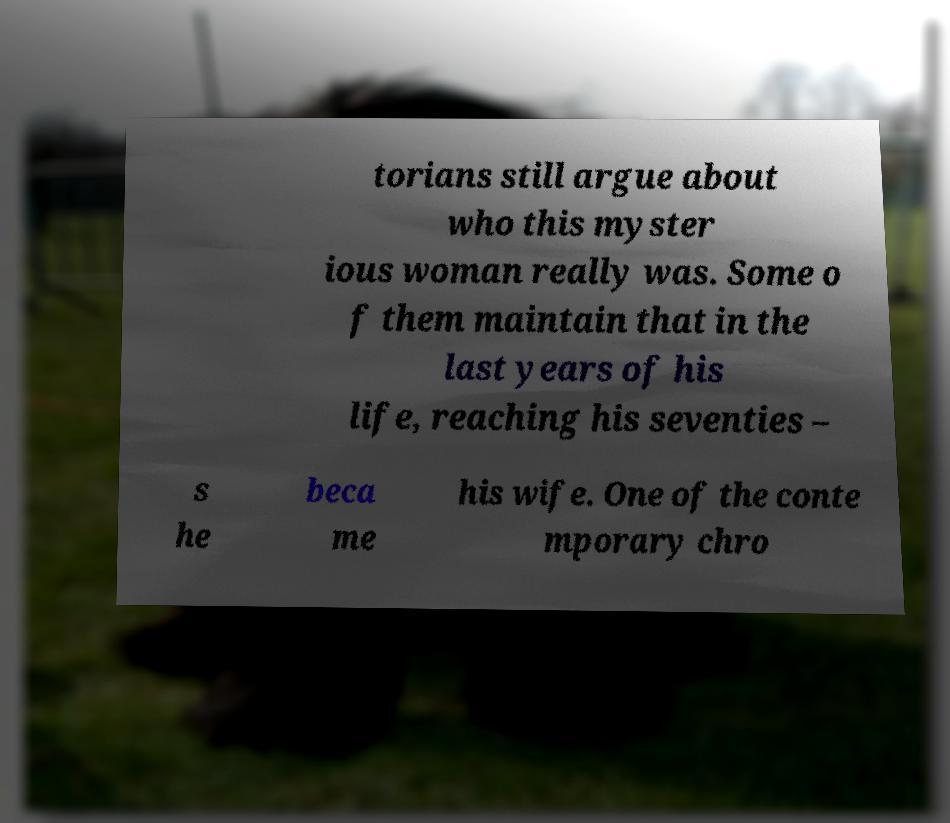There's text embedded in this image that I need extracted. Can you transcribe it verbatim? torians still argue about who this myster ious woman really was. Some o f them maintain that in the last years of his life, reaching his seventies – s he beca me his wife. One of the conte mporary chro 